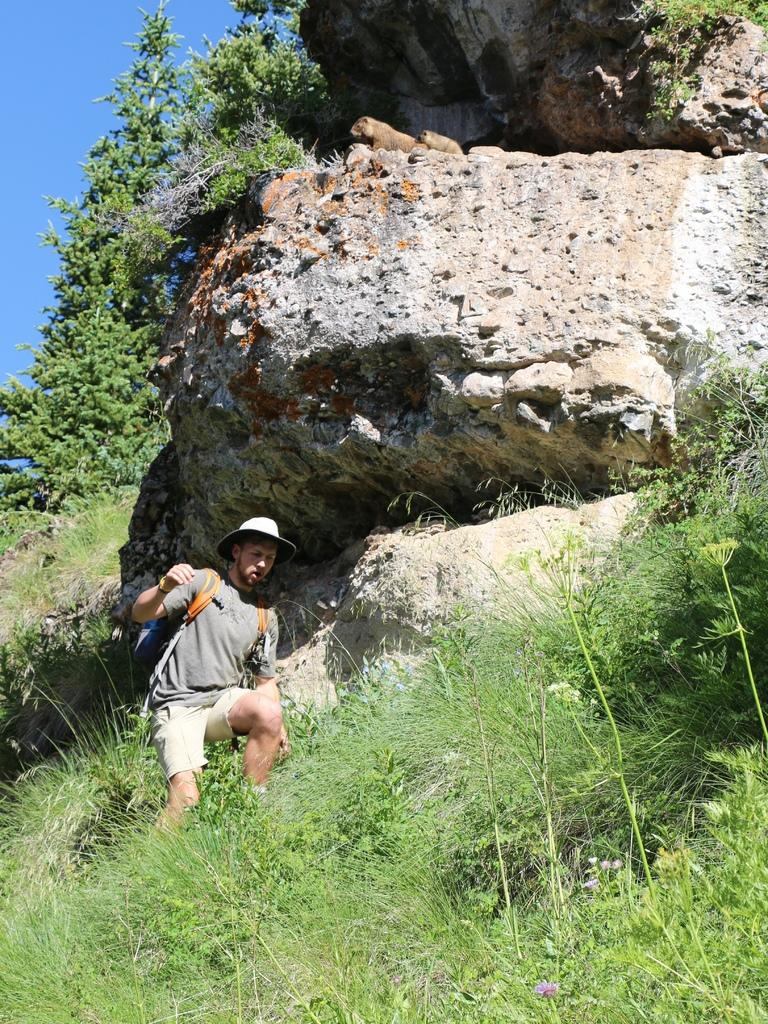Who is present in the image? There is a man in the image. What type of natural features can be seen in the image? There are huge rocks, grass, trees, and plants in the image. How many frogs can be seen coughing in the image? There are no frogs present in the image, and therefore no such activity can be observed. What sense is being utilized by the man in the image? The provided facts do not give information about the man's senses or actions, so it cannot be determined from the image. 